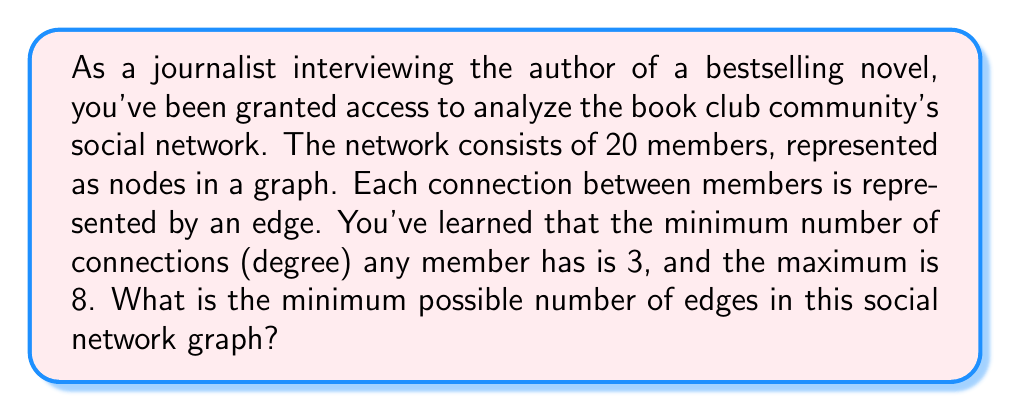Give your solution to this math problem. To solve this problem, we need to use concepts from graph theory:

1) First, recall the Handshaking Lemma: In any graph, the sum of degrees of all vertices is equal to twice the number of edges. Mathematically,

   $$\sum_{v \in V} \deg(v) = 2|E|$$

   where $V$ is the set of vertices and $E$ is the set of edges.

2) We're told that the minimum degree is 3 and the maximum is 8. To minimize the number of edges, we want as many vertices as possible to have the minimum degree.

3) Let $x$ be the number of vertices with degree 8, and $20-x$ be the number of vertices with degree 3.

4) We can set up an equation based on the Handshaking Lemma:

   $$8x + 3(20-x) = 2|E|$$

5) Simplify:
   $$8x + 60 - 3x = 2|E|$$
   $$5x + 60 = 2|E|$$

6) We want to minimize $|E|$, which means minimizing $x$. The smallest possible value for $x$ is 0.

7) With $x = 0$:
   $$60 = 2|E|$$
   $$|E| = 30$$

Therefore, the minimum possible number of edges is 30.
Answer: 30 edges 